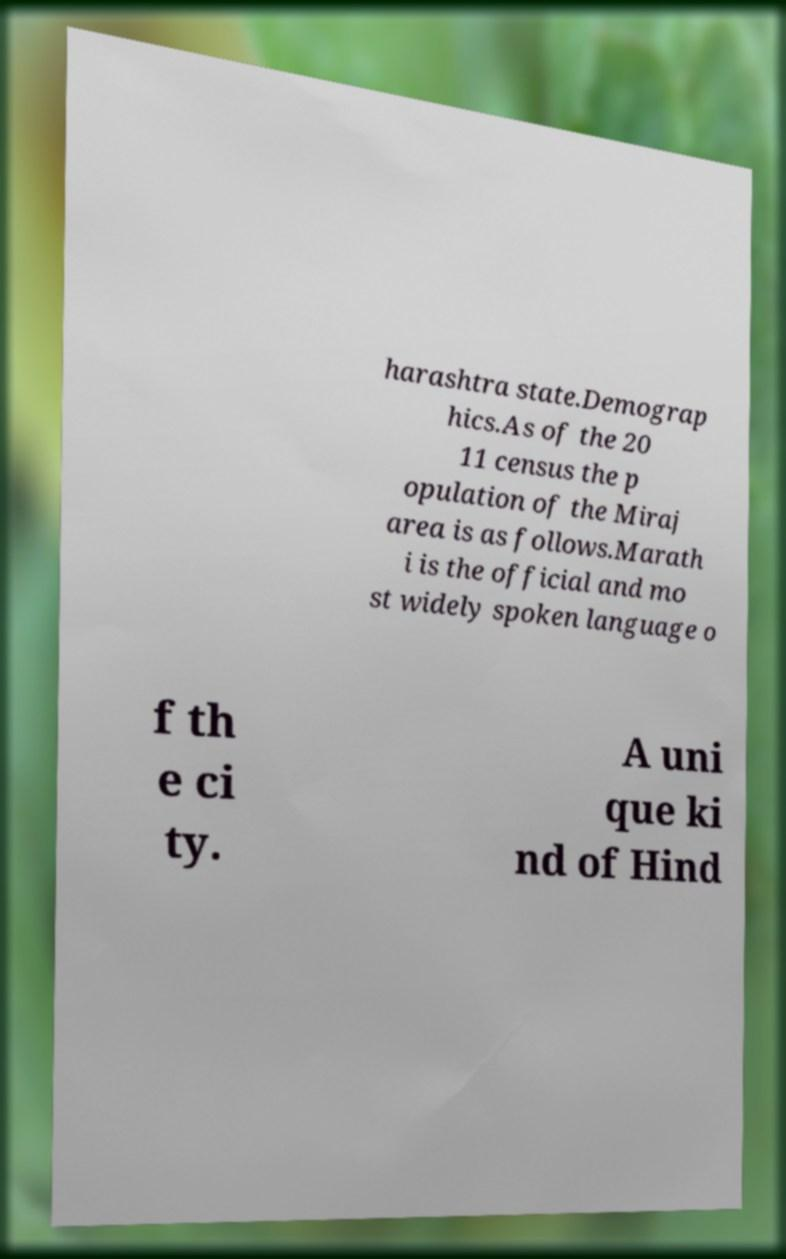Can you read and provide the text displayed in the image?This photo seems to have some interesting text. Can you extract and type it out for me? harashtra state.Demograp hics.As of the 20 11 census the p opulation of the Miraj area is as follows.Marath i is the official and mo st widely spoken language o f th e ci ty. A uni que ki nd of Hind 